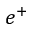Convert formula to latex. <formula><loc_0><loc_0><loc_500><loc_500>e ^ { + }</formula> 